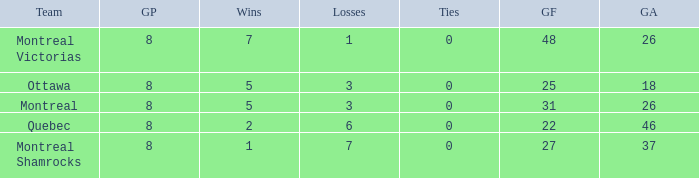How many losses did the team with 22 goals for andmore than 8 games played have? 0.0. 